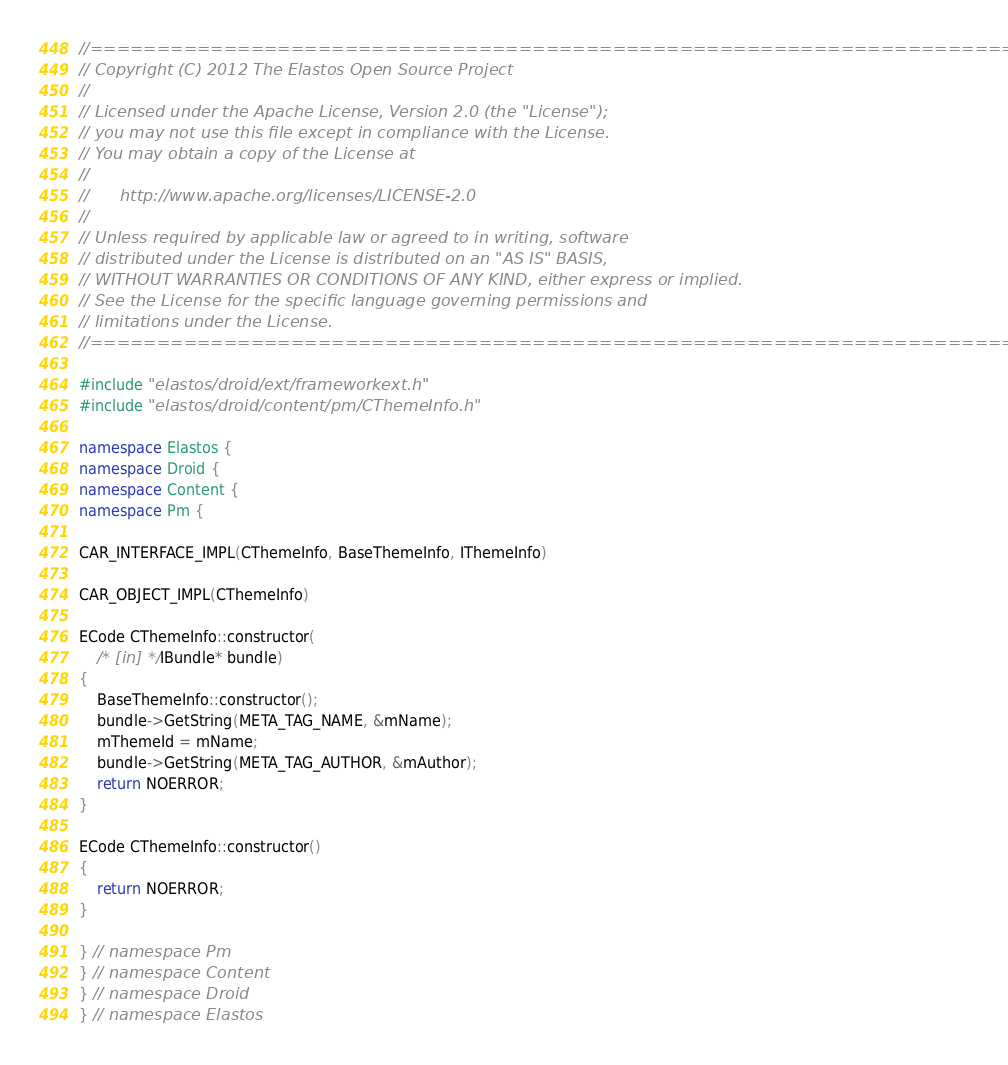<code> <loc_0><loc_0><loc_500><loc_500><_C++_>//=========================================================================
// Copyright (C) 2012 The Elastos Open Source Project
//
// Licensed under the Apache License, Version 2.0 (the "License");
// you may not use this file except in compliance with the License.
// You may obtain a copy of the License at
//
//      http://www.apache.org/licenses/LICENSE-2.0
//
// Unless required by applicable law or agreed to in writing, software
// distributed under the License is distributed on an "AS IS" BASIS,
// WITHOUT WARRANTIES OR CONDITIONS OF ANY KIND, either express or implied.
// See the License for the specific language governing permissions and
// limitations under the License.
//=========================================================================

#include "elastos/droid/ext/frameworkext.h"
#include "elastos/droid/content/pm/CThemeInfo.h"

namespace Elastos {
namespace Droid {
namespace Content {
namespace Pm {

CAR_INTERFACE_IMPL(CThemeInfo, BaseThemeInfo, IThemeInfo)

CAR_OBJECT_IMPL(CThemeInfo)

ECode CThemeInfo::constructor(
    /* [in] */ IBundle* bundle)
{
    BaseThemeInfo::constructor();
    bundle->GetString(META_TAG_NAME, &mName);
    mThemeId = mName;
    bundle->GetString(META_TAG_AUTHOR, &mAuthor);
    return NOERROR;
}

ECode CThemeInfo::constructor()
{
    return NOERROR;
}

} // namespace Pm
} // namespace Content
} // namespace Droid
} // namespace Elastos
</code> 